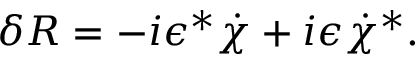<formula> <loc_0><loc_0><loc_500><loc_500>\delta R = - i \epsilon ^ { * } \dot { \chi } + i \epsilon \dot { \chi } ^ { * } .</formula> 